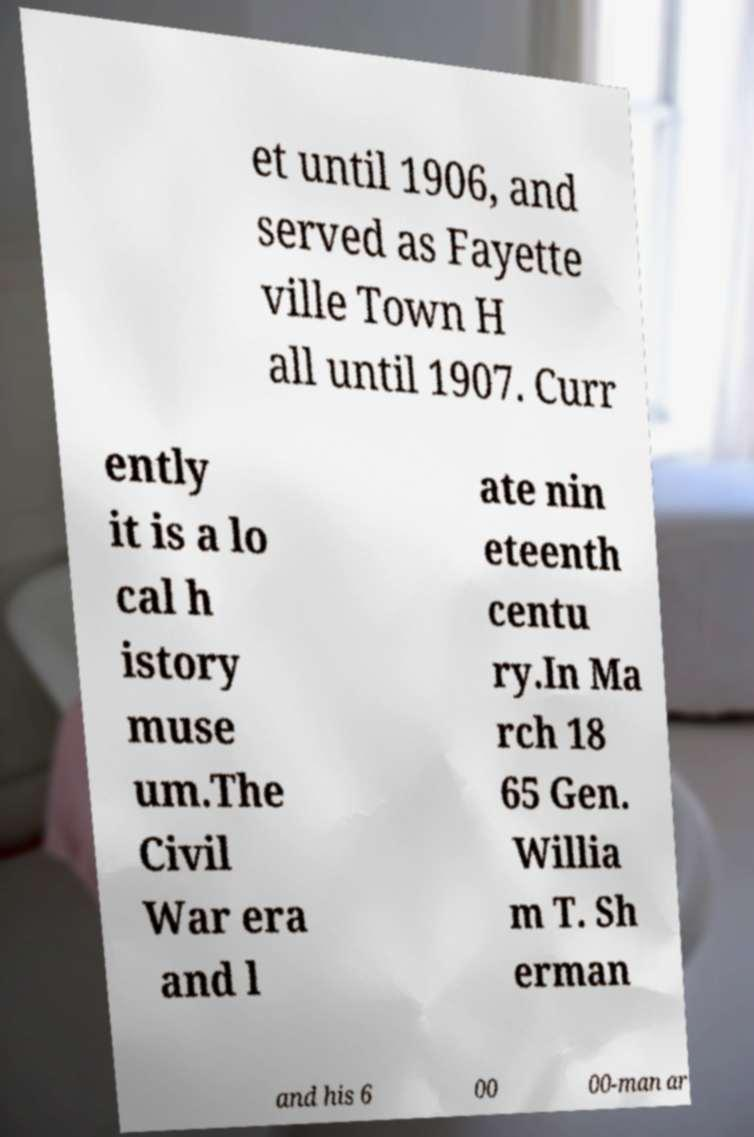Could you assist in decoding the text presented in this image and type it out clearly? et until 1906, and served as Fayette ville Town H all until 1907. Curr ently it is a lo cal h istory muse um.The Civil War era and l ate nin eteenth centu ry.In Ma rch 18 65 Gen. Willia m T. Sh erman and his 6 00 00-man ar 